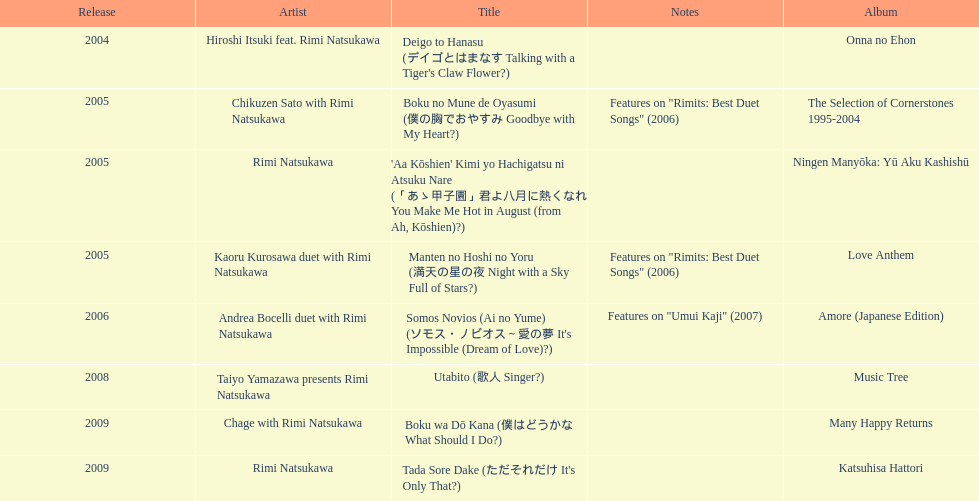What is the album that came out right before the one with "boku wa do kana" on it? Music Tree. 